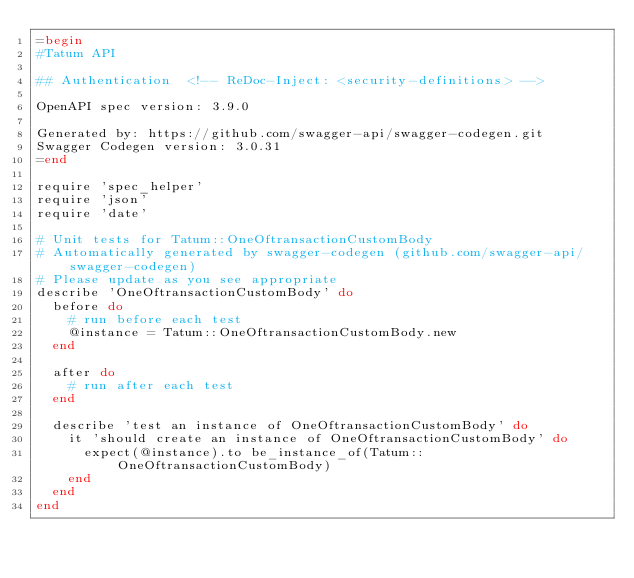Convert code to text. <code><loc_0><loc_0><loc_500><loc_500><_Ruby_>=begin
#Tatum API

## Authentication  <!-- ReDoc-Inject: <security-definitions> -->

OpenAPI spec version: 3.9.0

Generated by: https://github.com/swagger-api/swagger-codegen.git
Swagger Codegen version: 3.0.31
=end

require 'spec_helper'
require 'json'
require 'date'

# Unit tests for Tatum::OneOftransactionCustomBody
# Automatically generated by swagger-codegen (github.com/swagger-api/swagger-codegen)
# Please update as you see appropriate
describe 'OneOftransactionCustomBody' do
  before do
    # run before each test
    @instance = Tatum::OneOftransactionCustomBody.new
  end

  after do
    # run after each test
  end

  describe 'test an instance of OneOftransactionCustomBody' do
    it 'should create an instance of OneOftransactionCustomBody' do
      expect(@instance).to be_instance_of(Tatum::OneOftransactionCustomBody)
    end
  end
end
</code> 